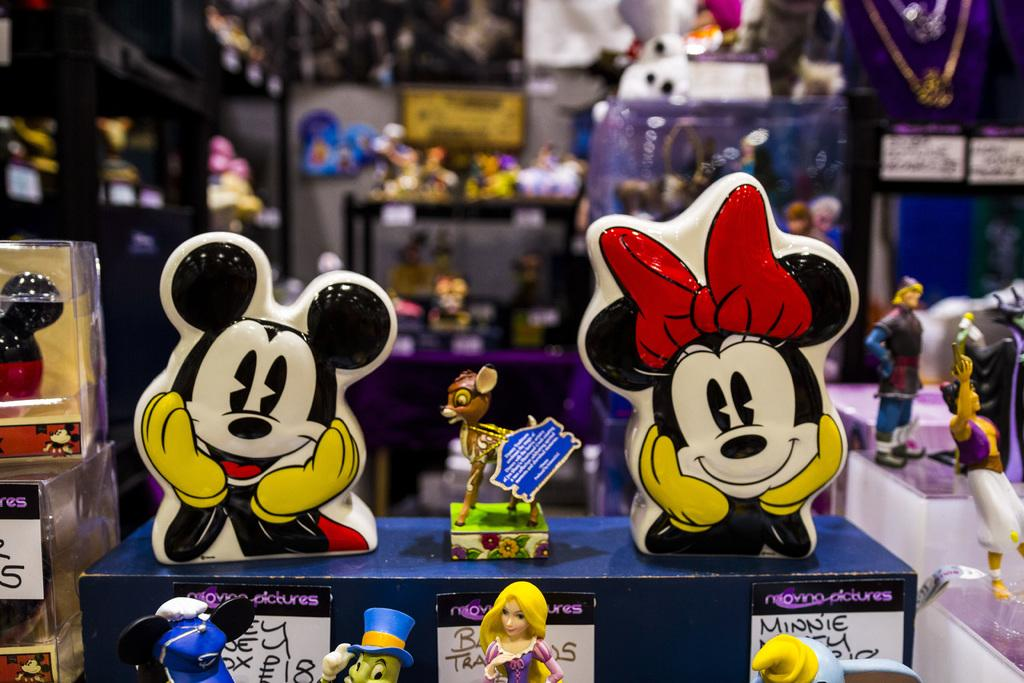What type of establishment is shown in the image? There is a store in the image. What kind of items can be found in the store? The store contains toys. How can customers determine the price of the toys? Price boards are fixed under the toys. What time of day is it in the image, and how does the store stop selling toys at night? The time of day is not mentioned in the image, and there is no indication that the store stops selling toys at night. 